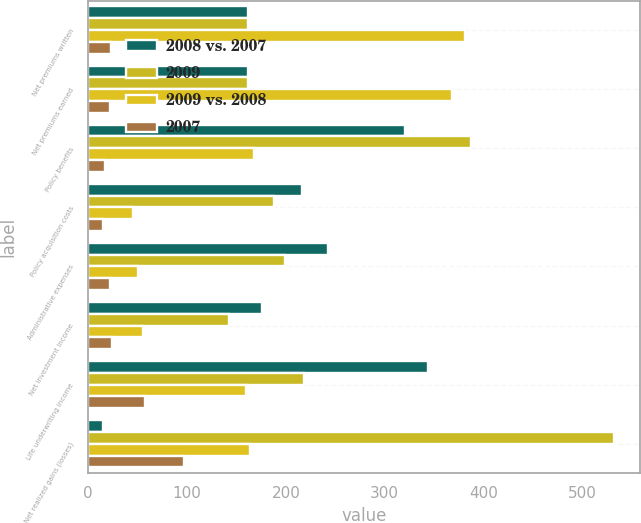Convert chart to OTSL. <chart><loc_0><loc_0><loc_500><loc_500><stacked_bar_chart><ecel><fcel>Net premiums written<fcel>Net premiums earned<fcel>Policy benefits<fcel>Policy acquisition costs<fcel>Administrative expenses<fcel>Net investment income<fcel>Life underwriting income<fcel>Net realized gains (losses)<nl><fcel>2008 vs. 2007<fcel>162<fcel>162<fcel>321<fcel>216<fcel>243<fcel>176<fcel>344<fcel>15<nl><fcel>2009<fcel>162<fcel>162<fcel>387<fcel>188<fcel>199<fcel>142<fcel>218<fcel>532<nl><fcel>2009 vs. 2008<fcel>381<fcel>368<fcel>168<fcel>45<fcel>50<fcel>55<fcel>160<fcel>164<nl><fcel>2007<fcel>23<fcel>22<fcel>17<fcel>15<fcel>22<fcel>24<fcel>58<fcel>97<nl></chart> 